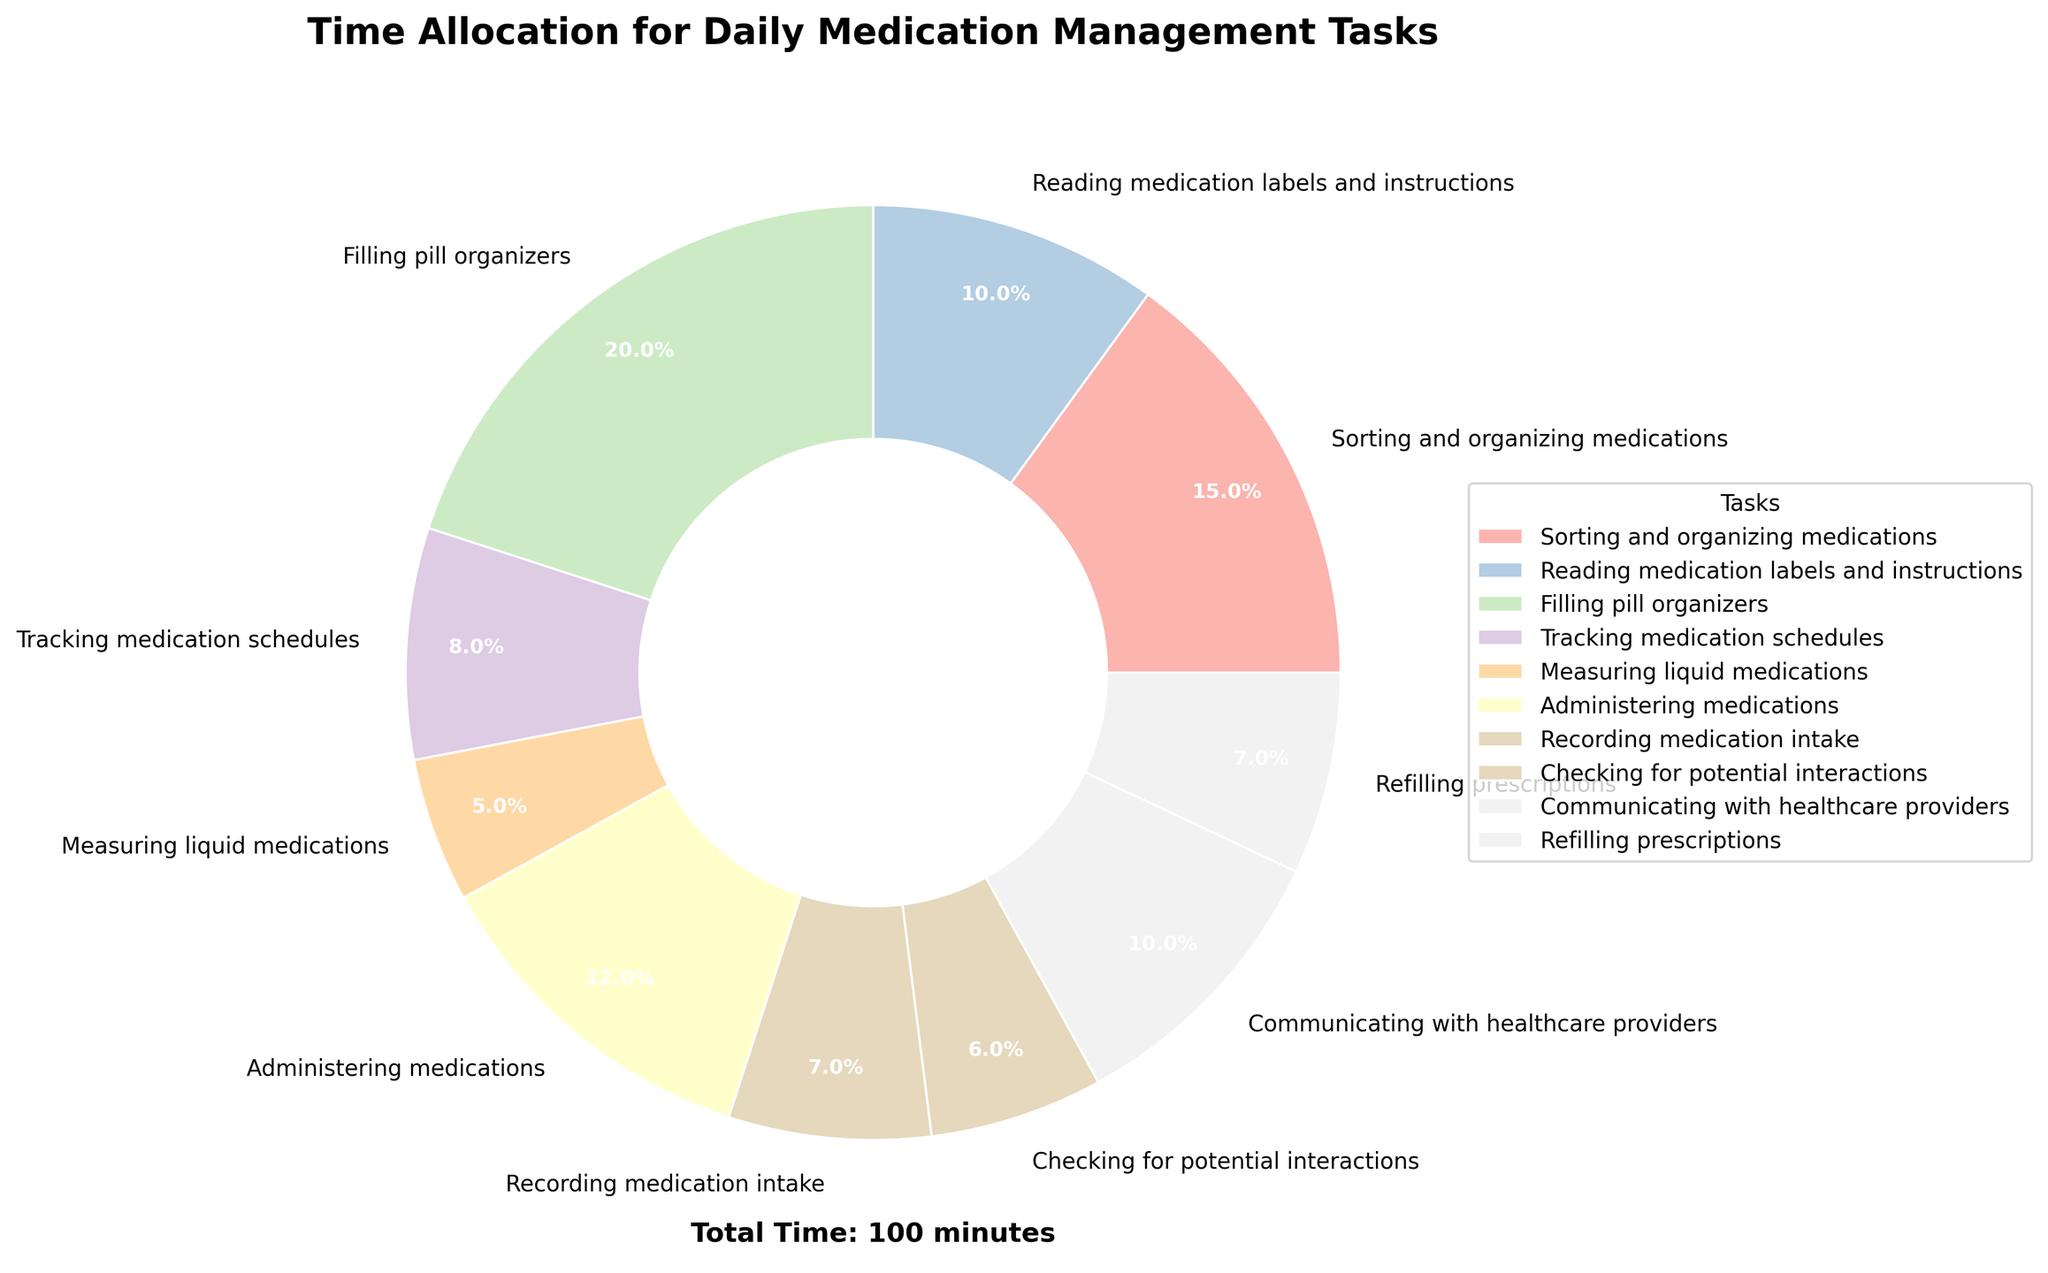What is the total time spent on "Filling pill organizers" and "Administering medications"? The time for "Filling pill organizers" is 20 minutes, and the time for "Administering medications" is 12 minutes. Adding these together, 20 + 12 = 32 minutes.
Answer: 32 minutes Which task has the shortest duration, and how much time is allocated to it? Looking at the pie chart, the task with the shortest duration is "Measuring liquid medications" with a time allocation of 5 minutes.
Answer: Measuring liquid medications, 5 minutes How much more time is spent on "Filling pill organizers" compared to "Recording medication intake"? The time spent on "Filling pill organizers" is 20 minutes, and the time spent on "Recording medication intake" is 7 minutes. The difference is 20 - 7 = 13 minutes.
Answer: 13 minutes What percentage of the total time is allocated to "Tracking medication schedules" and how does it compare to the percentage allocated to "Refilling prescriptions"? "Tracking medication schedules" takes 8 minutes, and "Refilling prescriptions" takes 7 minutes. To find the percentage, divide each by the total time (which is 100 minutes).
So, for "Tracking medication schedules": (8/100)*100 = 8%
For "Refilling prescriptions": (7/100)*100 = 7%
"Tracking medication schedules" is 1% more than "Refilling prescriptions".
Answer: 8%, 7% Which task uses the most time and how much is it? The longest time is spent on "Filling pill organizers" with 20 minutes.
Answer: Filling pill organizers, 20 minutes 